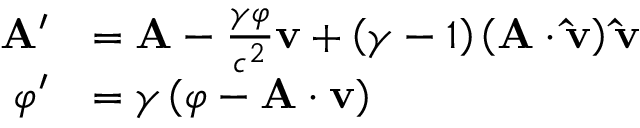Convert formula to latex. <formula><loc_0><loc_0><loc_500><loc_500>{ \begin{array} { r l } { A ^ { \prime } } & { = A - { \frac { \gamma \varphi } { c ^ { 2 } } } v + \left ( \gamma - 1 \right ) \left ( A \cdot \hat { v } \right ) \hat { v } } \\ { \varphi ^ { \prime } } & { = \gamma \left ( \varphi - A \cdot v \right ) } \end{array} }</formula> 